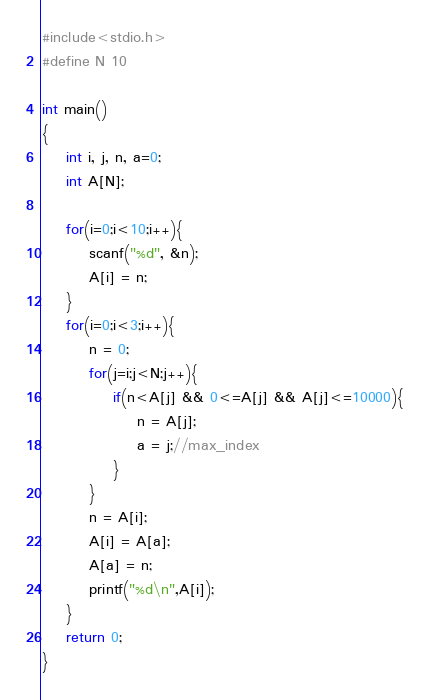Convert code to text. <code><loc_0><loc_0><loc_500><loc_500><_C_>#include<stdio.h>
#define N 10

int main()
{
    int i, j, n, a=0;
    int A[N];

    for(i=0;i<10;i++){
        scanf("%d", &n);
        A[i] = n;
    }
    for(i=0;i<3;i++){
        n = 0;
        for(j=i;j<N;j++){
            if(n<A[j] && 0<=A[j] && A[j]<=10000){
                n = A[j];
                a = j;//max_index
            }
        }
        n = A[i];
        A[i] = A[a];
        A[a] = n;
        printf("%d\n",A[i]);
    }
    return 0;
}</code> 